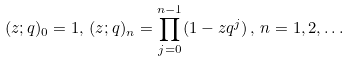Convert formula to latex. <formula><loc_0><loc_0><loc_500><loc_500>( z ; q ) _ { 0 } = 1 , \, ( z ; q ) _ { n } = \prod _ { j = 0 } ^ { n - 1 } ( 1 - z q ^ { j } ) \, , \, n = 1 , 2 , \dots</formula> 